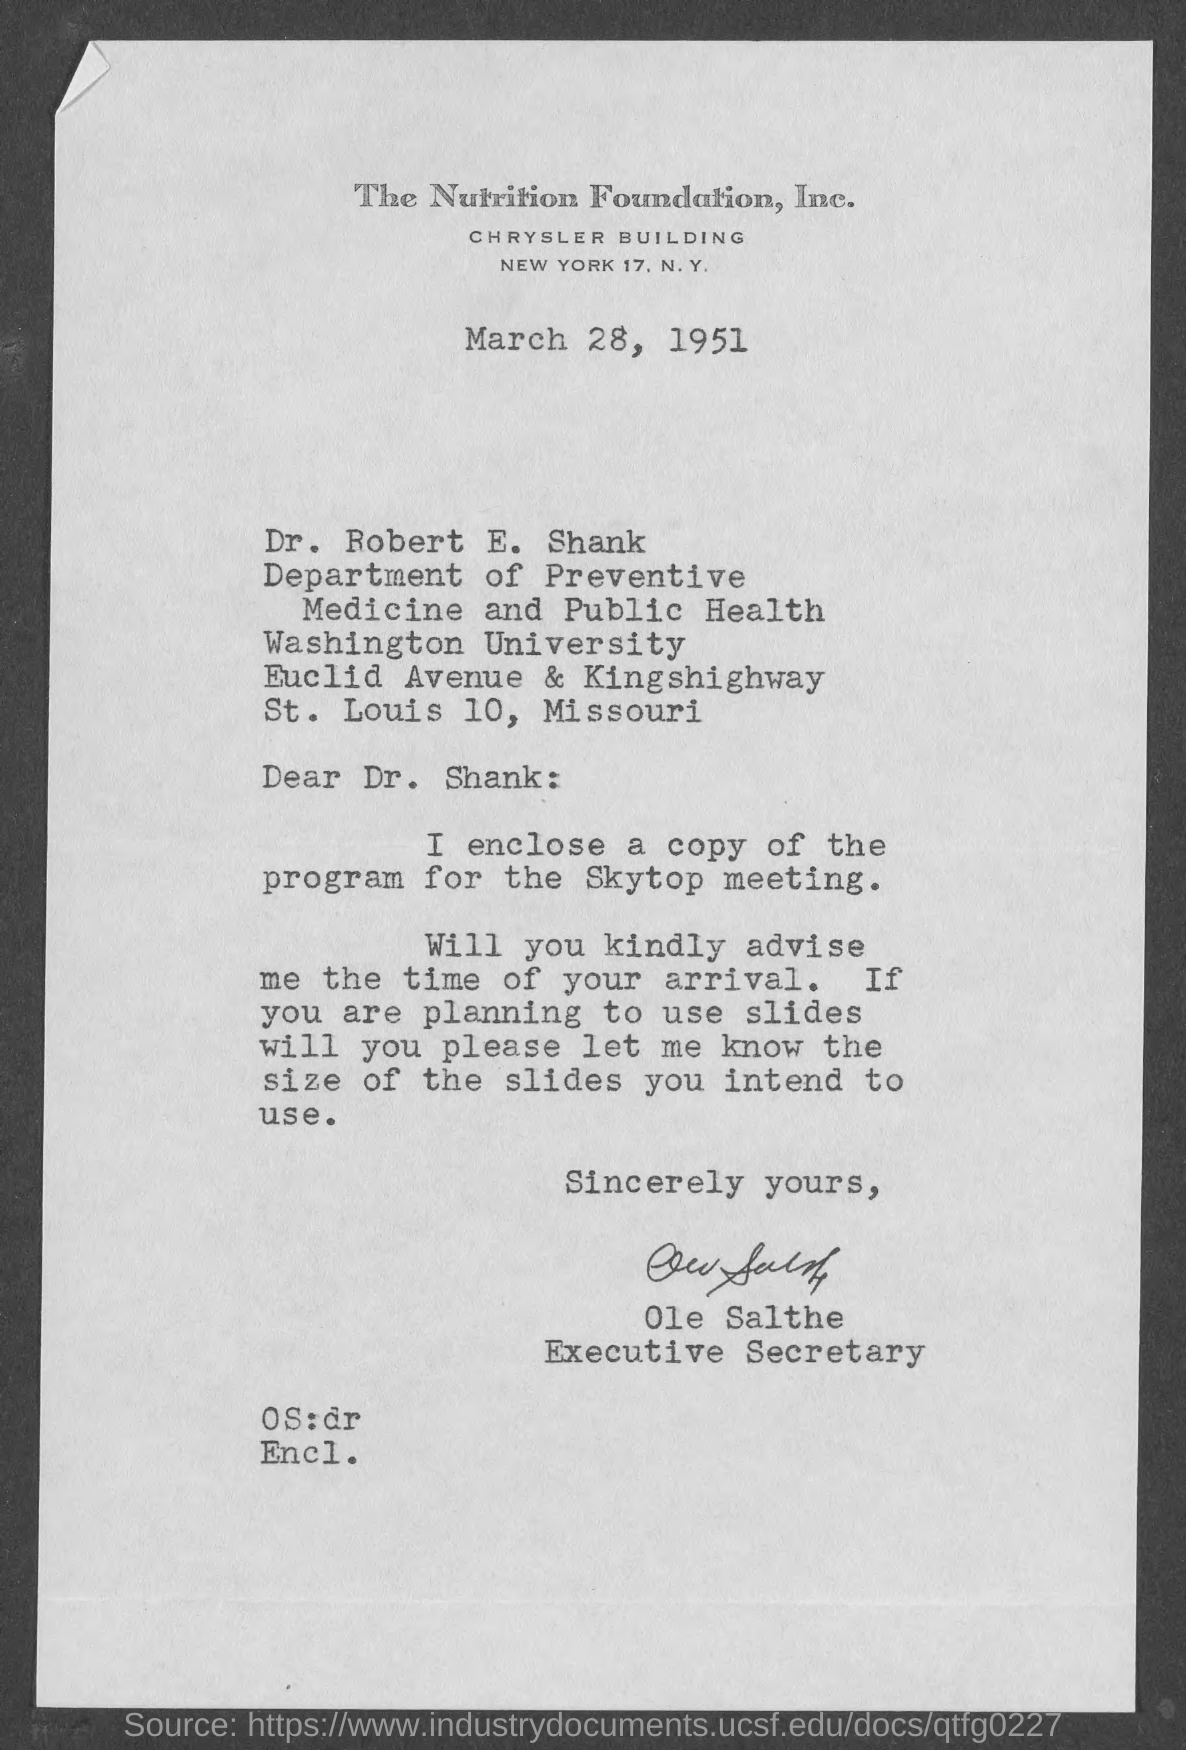Give some essential details in this illustration. The date on the document is March 28, 1951. The enclosed copy is a program for the Skytop meeting. The letter is addressed to Dr. Robert E. Shank. The letter is from the Executive Secretary. 